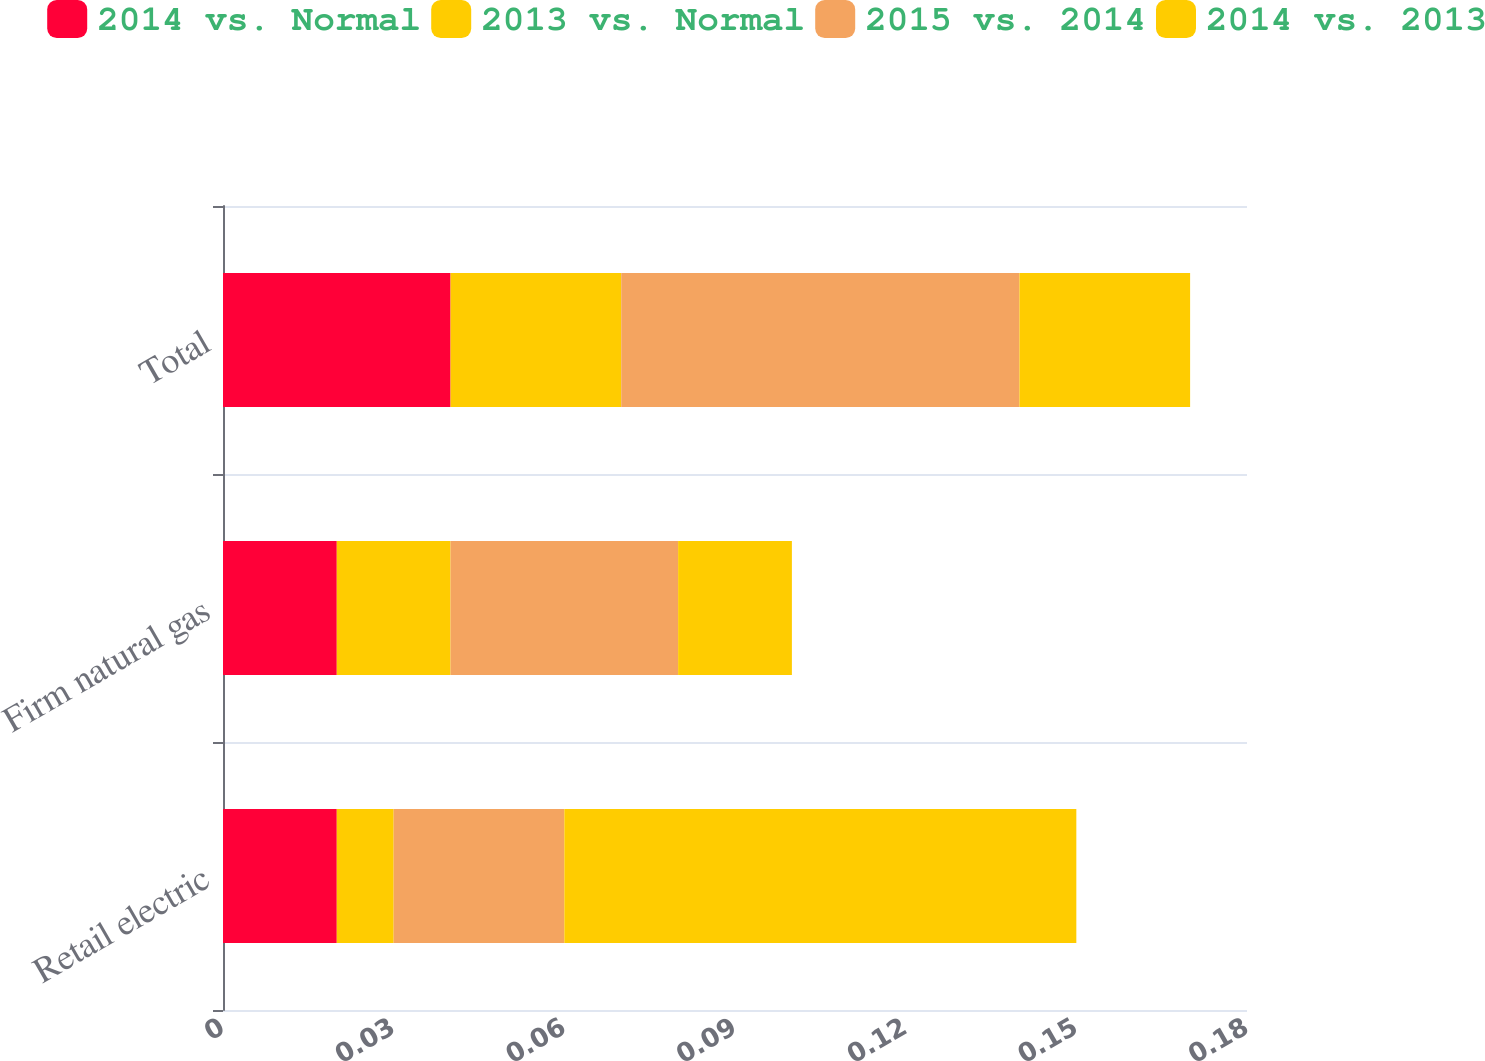Convert chart. <chart><loc_0><loc_0><loc_500><loc_500><stacked_bar_chart><ecel><fcel>Retail electric<fcel>Firm natural gas<fcel>Total<nl><fcel>2014 vs. Normal<fcel>0.02<fcel>0.02<fcel>0.04<nl><fcel>2013 vs. Normal<fcel>0.01<fcel>0.02<fcel>0.03<nl><fcel>2015 vs. 2014<fcel>0.03<fcel>0.04<fcel>0.07<nl><fcel>2014 vs. 2013<fcel>0.09<fcel>0.02<fcel>0.03<nl></chart> 